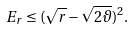<formula> <loc_0><loc_0><loc_500><loc_500>E _ { r } \leq ( \sqrt { r } - \sqrt { 2 \vartheta } ) ^ { 2 } .</formula> 